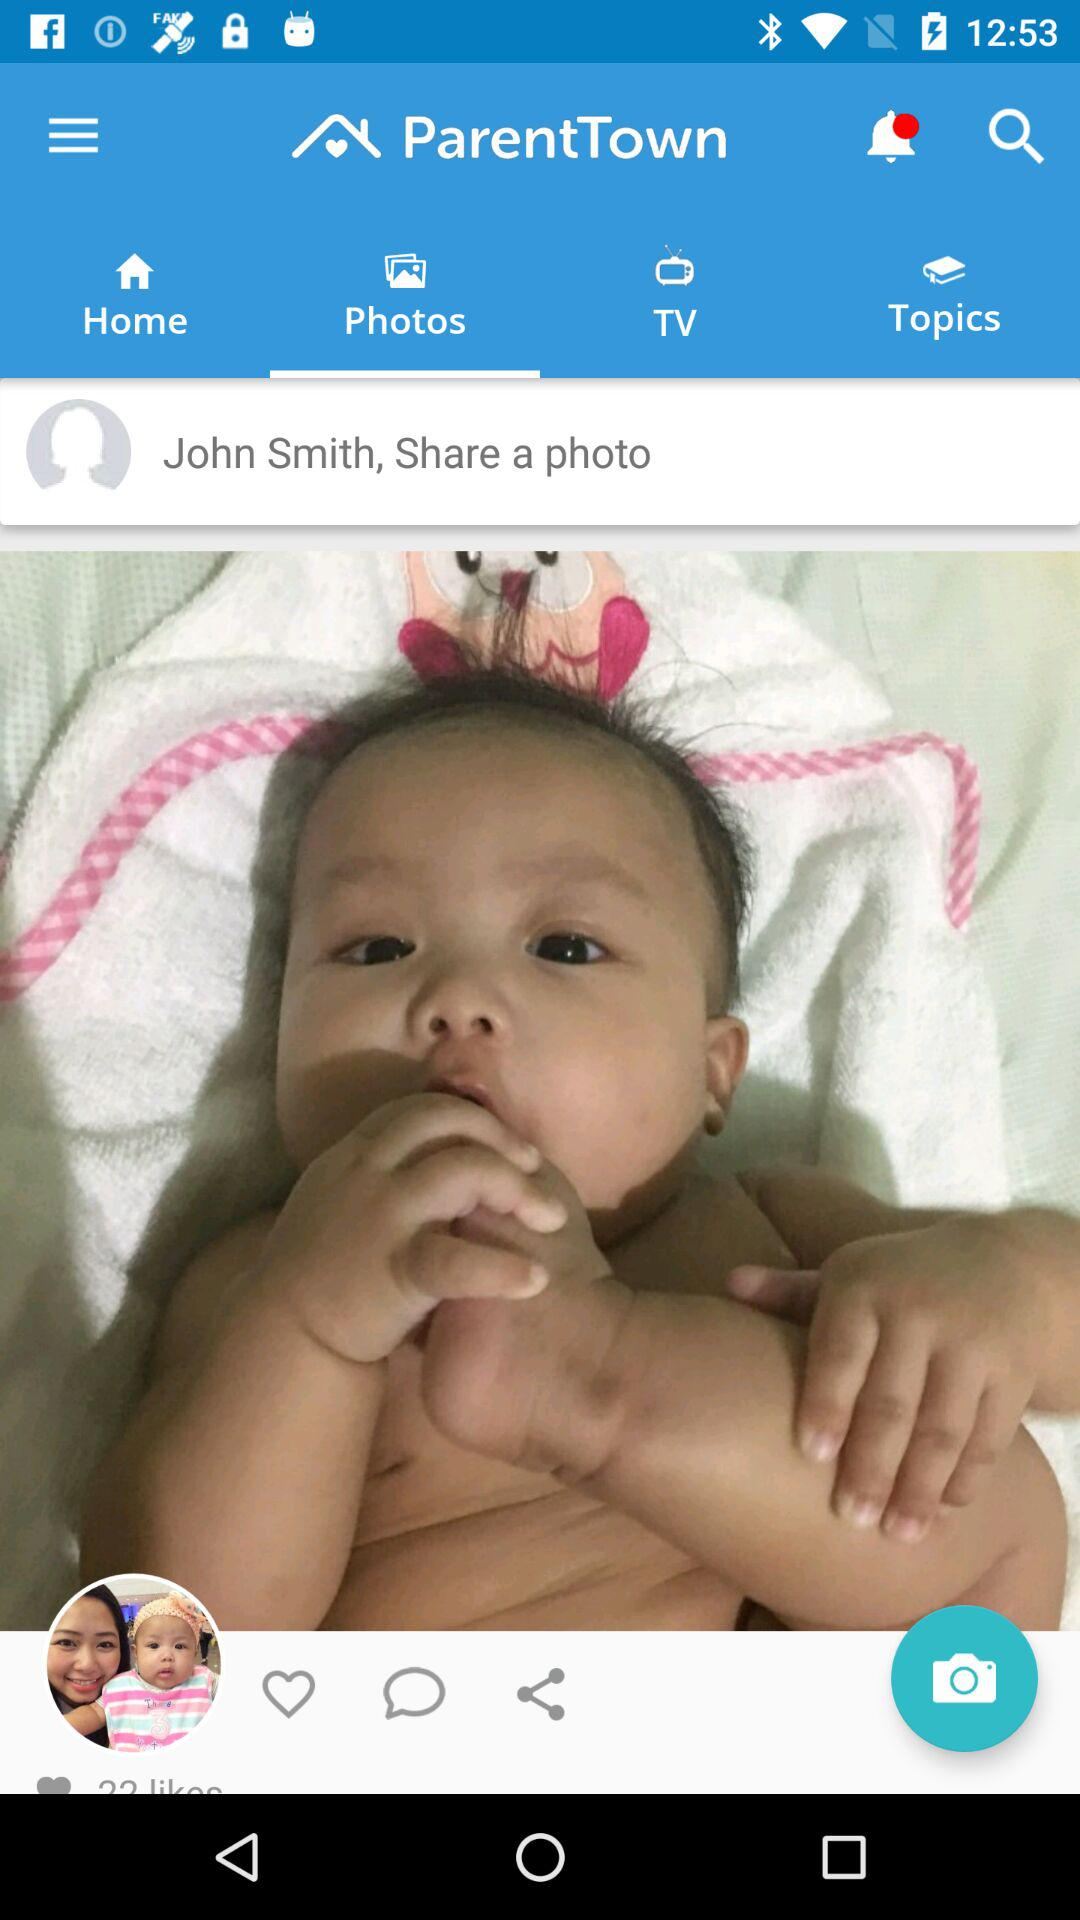What is the selected tab? The selected tab is "Photos". 